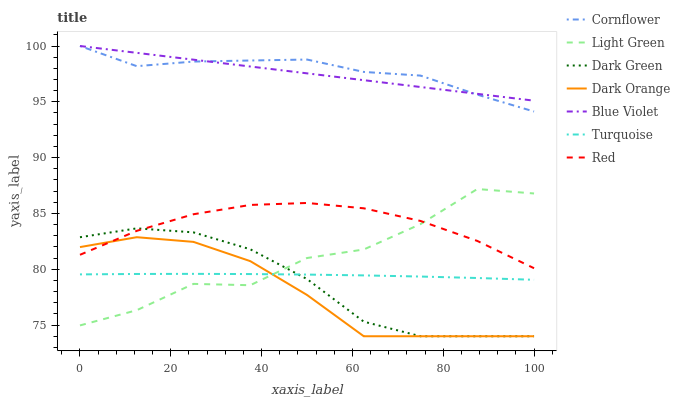Does Dark Orange have the minimum area under the curve?
Answer yes or no. Yes. Does Cornflower have the maximum area under the curve?
Answer yes or no. Yes. Does Turquoise have the minimum area under the curve?
Answer yes or no. No. Does Turquoise have the maximum area under the curve?
Answer yes or no. No. Is Blue Violet the smoothest?
Answer yes or no. Yes. Is Light Green the roughest?
Answer yes or no. Yes. Is Turquoise the smoothest?
Answer yes or no. No. Is Turquoise the roughest?
Answer yes or no. No. Does Dark Orange have the lowest value?
Answer yes or no. Yes. Does Turquoise have the lowest value?
Answer yes or no. No. Does Blue Violet have the highest value?
Answer yes or no. Yes. Does Turquoise have the highest value?
Answer yes or no. No. Is Dark Green less than Blue Violet?
Answer yes or no. Yes. Is Red greater than Turquoise?
Answer yes or no. Yes. Does Dark Orange intersect Dark Green?
Answer yes or no. Yes. Is Dark Orange less than Dark Green?
Answer yes or no. No. Is Dark Orange greater than Dark Green?
Answer yes or no. No. Does Dark Green intersect Blue Violet?
Answer yes or no. No. 